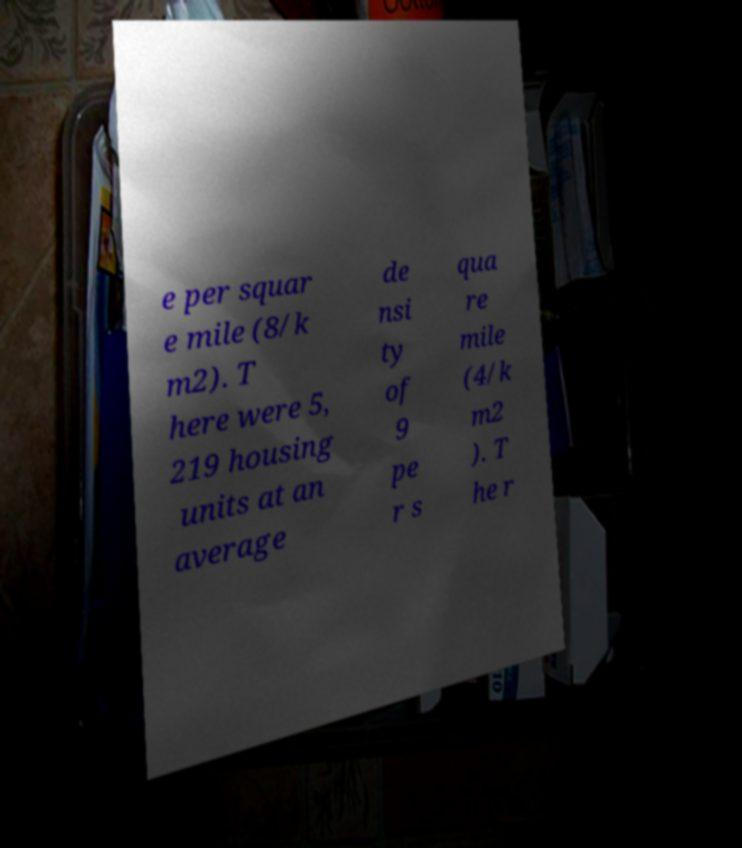There's text embedded in this image that I need extracted. Can you transcribe it verbatim? e per squar e mile (8/k m2). T here were 5, 219 housing units at an average de nsi ty of 9 pe r s qua re mile (4/k m2 ). T he r 